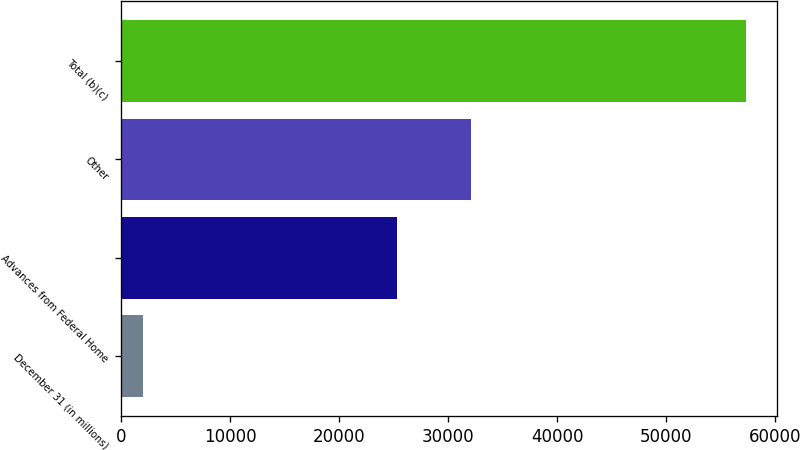<chart> <loc_0><loc_0><loc_500><loc_500><bar_chart><fcel>December 31 (in millions)<fcel>Advances from Federal Home<fcel>Other<fcel>Total (b)(c)<nl><fcel>2010<fcel>25234<fcel>32075<fcel>57309<nl></chart> 